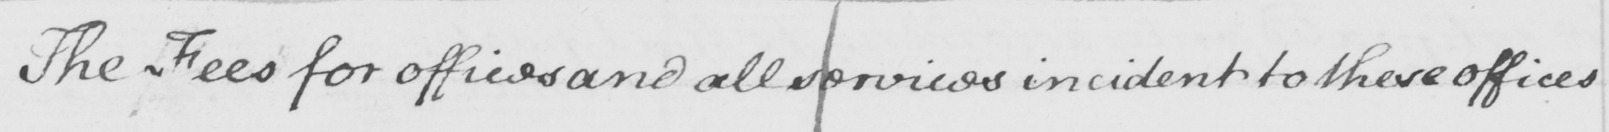What text is written in this handwritten line? The Fees for offices and all services incident to these offices 